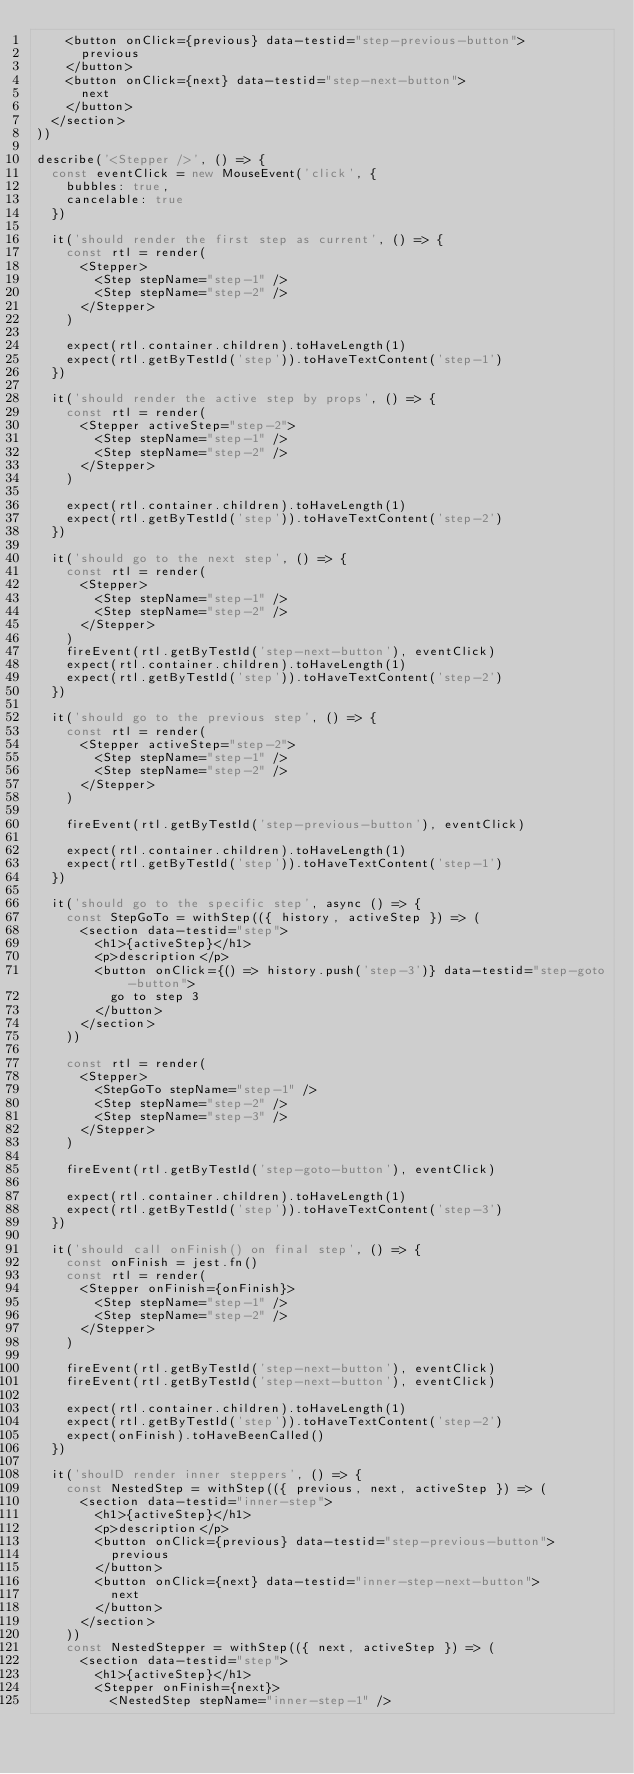<code> <loc_0><loc_0><loc_500><loc_500><_JavaScript_>    <button onClick={previous} data-testid="step-previous-button">
      previous
    </button>
    <button onClick={next} data-testid="step-next-button">
      next
    </button>
  </section>
))

describe('<Stepper />', () => {
  const eventClick = new MouseEvent('click', {
    bubbles: true,
    cancelable: true
  })

  it('should render the first step as current', () => {
    const rtl = render(
      <Stepper>
        <Step stepName="step-1" />
        <Step stepName="step-2" />
      </Stepper>
    )

    expect(rtl.container.children).toHaveLength(1)
    expect(rtl.getByTestId('step')).toHaveTextContent('step-1')
  })

  it('should render the active step by props', () => {
    const rtl = render(
      <Stepper activeStep="step-2">
        <Step stepName="step-1" />
        <Step stepName="step-2" />
      </Stepper>
    )

    expect(rtl.container.children).toHaveLength(1)
    expect(rtl.getByTestId('step')).toHaveTextContent('step-2')
  })

  it('should go to the next step', () => {
    const rtl = render(
      <Stepper>
        <Step stepName="step-1" />
        <Step stepName="step-2" />
      </Stepper>
    )
    fireEvent(rtl.getByTestId('step-next-button'), eventClick)
    expect(rtl.container.children).toHaveLength(1)
    expect(rtl.getByTestId('step')).toHaveTextContent('step-2')
  })

  it('should go to the previous step', () => {
    const rtl = render(
      <Stepper activeStep="step-2">
        <Step stepName="step-1" />
        <Step stepName="step-2" />
      </Stepper>
    )

    fireEvent(rtl.getByTestId('step-previous-button'), eventClick)

    expect(rtl.container.children).toHaveLength(1)
    expect(rtl.getByTestId('step')).toHaveTextContent('step-1')
  })

  it('should go to the specific step', async () => {
    const StepGoTo = withStep(({ history, activeStep }) => (
      <section data-testid="step">
        <h1>{activeStep}</h1>
        <p>description</p>
        <button onClick={() => history.push('step-3')} data-testid="step-goto-button">
          go to step 3
        </button>
      </section>
    ))

    const rtl = render(
      <Stepper>
        <StepGoTo stepName="step-1" />
        <Step stepName="step-2" />
        <Step stepName="step-3" />
      </Stepper>
    )

    fireEvent(rtl.getByTestId('step-goto-button'), eventClick)

    expect(rtl.container.children).toHaveLength(1)
    expect(rtl.getByTestId('step')).toHaveTextContent('step-3')
  })

  it('should call onFinish() on final step', () => {
    const onFinish = jest.fn()
    const rtl = render(
      <Stepper onFinish={onFinish}>
        <Step stepName="step-1" />
        <Step stepName="step-2" />
      </Stepper>
    )

    fireEvent(rtl.getByTestId('step-next-button'), eventClick)
    fireEvent(rtl.getByTestId('step-next-button'), eventClick)

    expect(rtl.container.children).toHaveLength(1)
    expect(rtl.getByTestId('step')).toHaveTextContent('step-2')
    expect(onFinish).toHaveBeenCalled()
  })

  it('shoulD render inner steppers', () => {
    const NestedStep = withStep(({ previous, next, activeStep }) => (
      <section data-testid="inner-step">
        <h1>{activeStep}</h1>
        <p>description</p>
        <button onClick={previous} data-testid="step-previous-button">
          previous
        </button>
        <button onClick={next} data-testid="inner-step-next-button">
          next
        </button>
      </section>
    ))
    const NestedStepper = withStep(({ next, activeStep }) => (
      <section data-testid="step">
        <h1>{activeStep}</h1>
        <Stepper onFinish={next}>
          <NestedStep stepName="inner-step-1" /></code> 